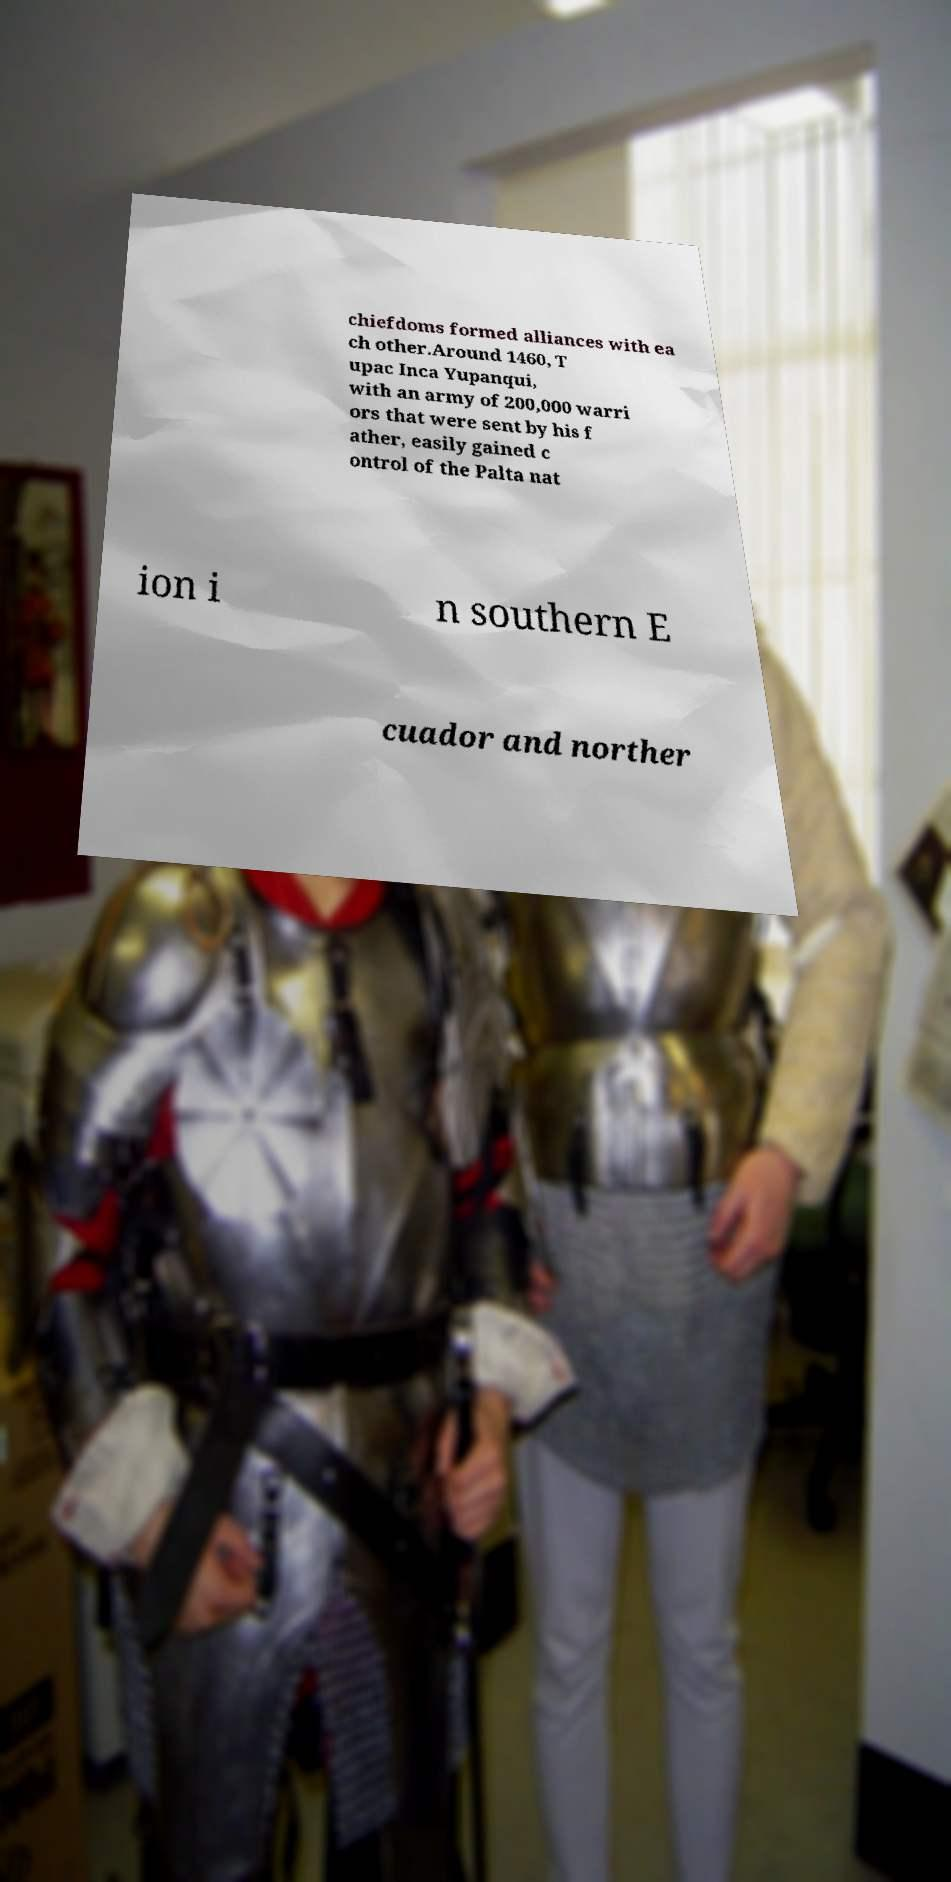Can you read and provide the text displayed in the image?This photo seems to have some interesting text. Can you extract and type it out for me? chiefdoms formed alliances with ea ch other.Around 1460, T upac Inca Yupanqui, with an army of 200,000 warri ors that were sent by his f ather, easily gained c ontrol of the Palta nat ion i n southern E cuador and norther 